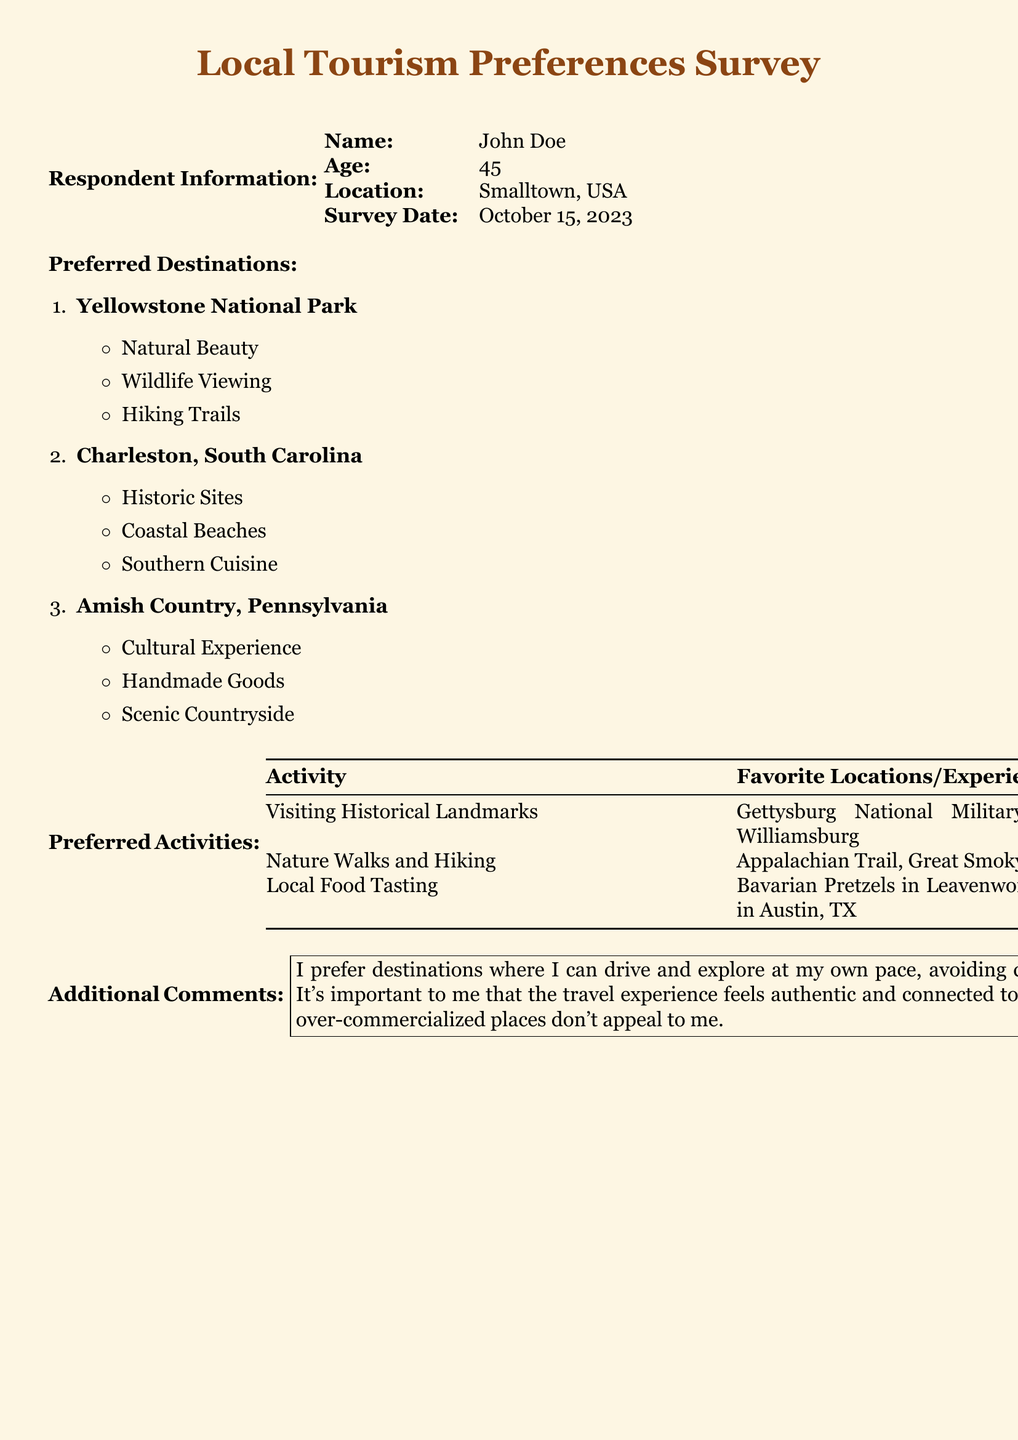What is the name of the respondent? The name of the respondent is presented at the top of the document under "Respondent Information."
Answer: John Doe How old is the respondent? The age of the respondent is listed next to the "Age" label in the document.
Answer: 45 What is the survey date? The date the survey was completed is mentioned under "Survey Date" in the document.
Answer: October 15, 2023 Which destination is preferred for wildlife viewing? The preferred destinations include activities, and wildlife viewing is associated with Yellowstone National Park.
Answer: Yellowstone National Park What activity is associated with local food tasting? The preferred activities include favorite locations or experiences, with local food tasting mentioned specifically.
Answer: Bavarian Pretzels in Leavenworth, WA; Barbecue in Austin, TX What does the respondent prefer in terms of travel experiences? The additional comments section describes the preferences for authentic and non-commercial travel experiences.
Answer: Authentic and connected to local culture How many preferred destinations are listed? The preferred destinations are numbered, and counting them gives the total.
Answer: 3 What type of activities does the respondent enjoy in nature? The activities section lists nature walks and hiking as a preference.
Answer: Nature Walks and Hiking What kind of destination does the respondent avoid? The document states preferences regarding tourism environment mentioned in the additional comments.
Answer: Crowded tourist spots 